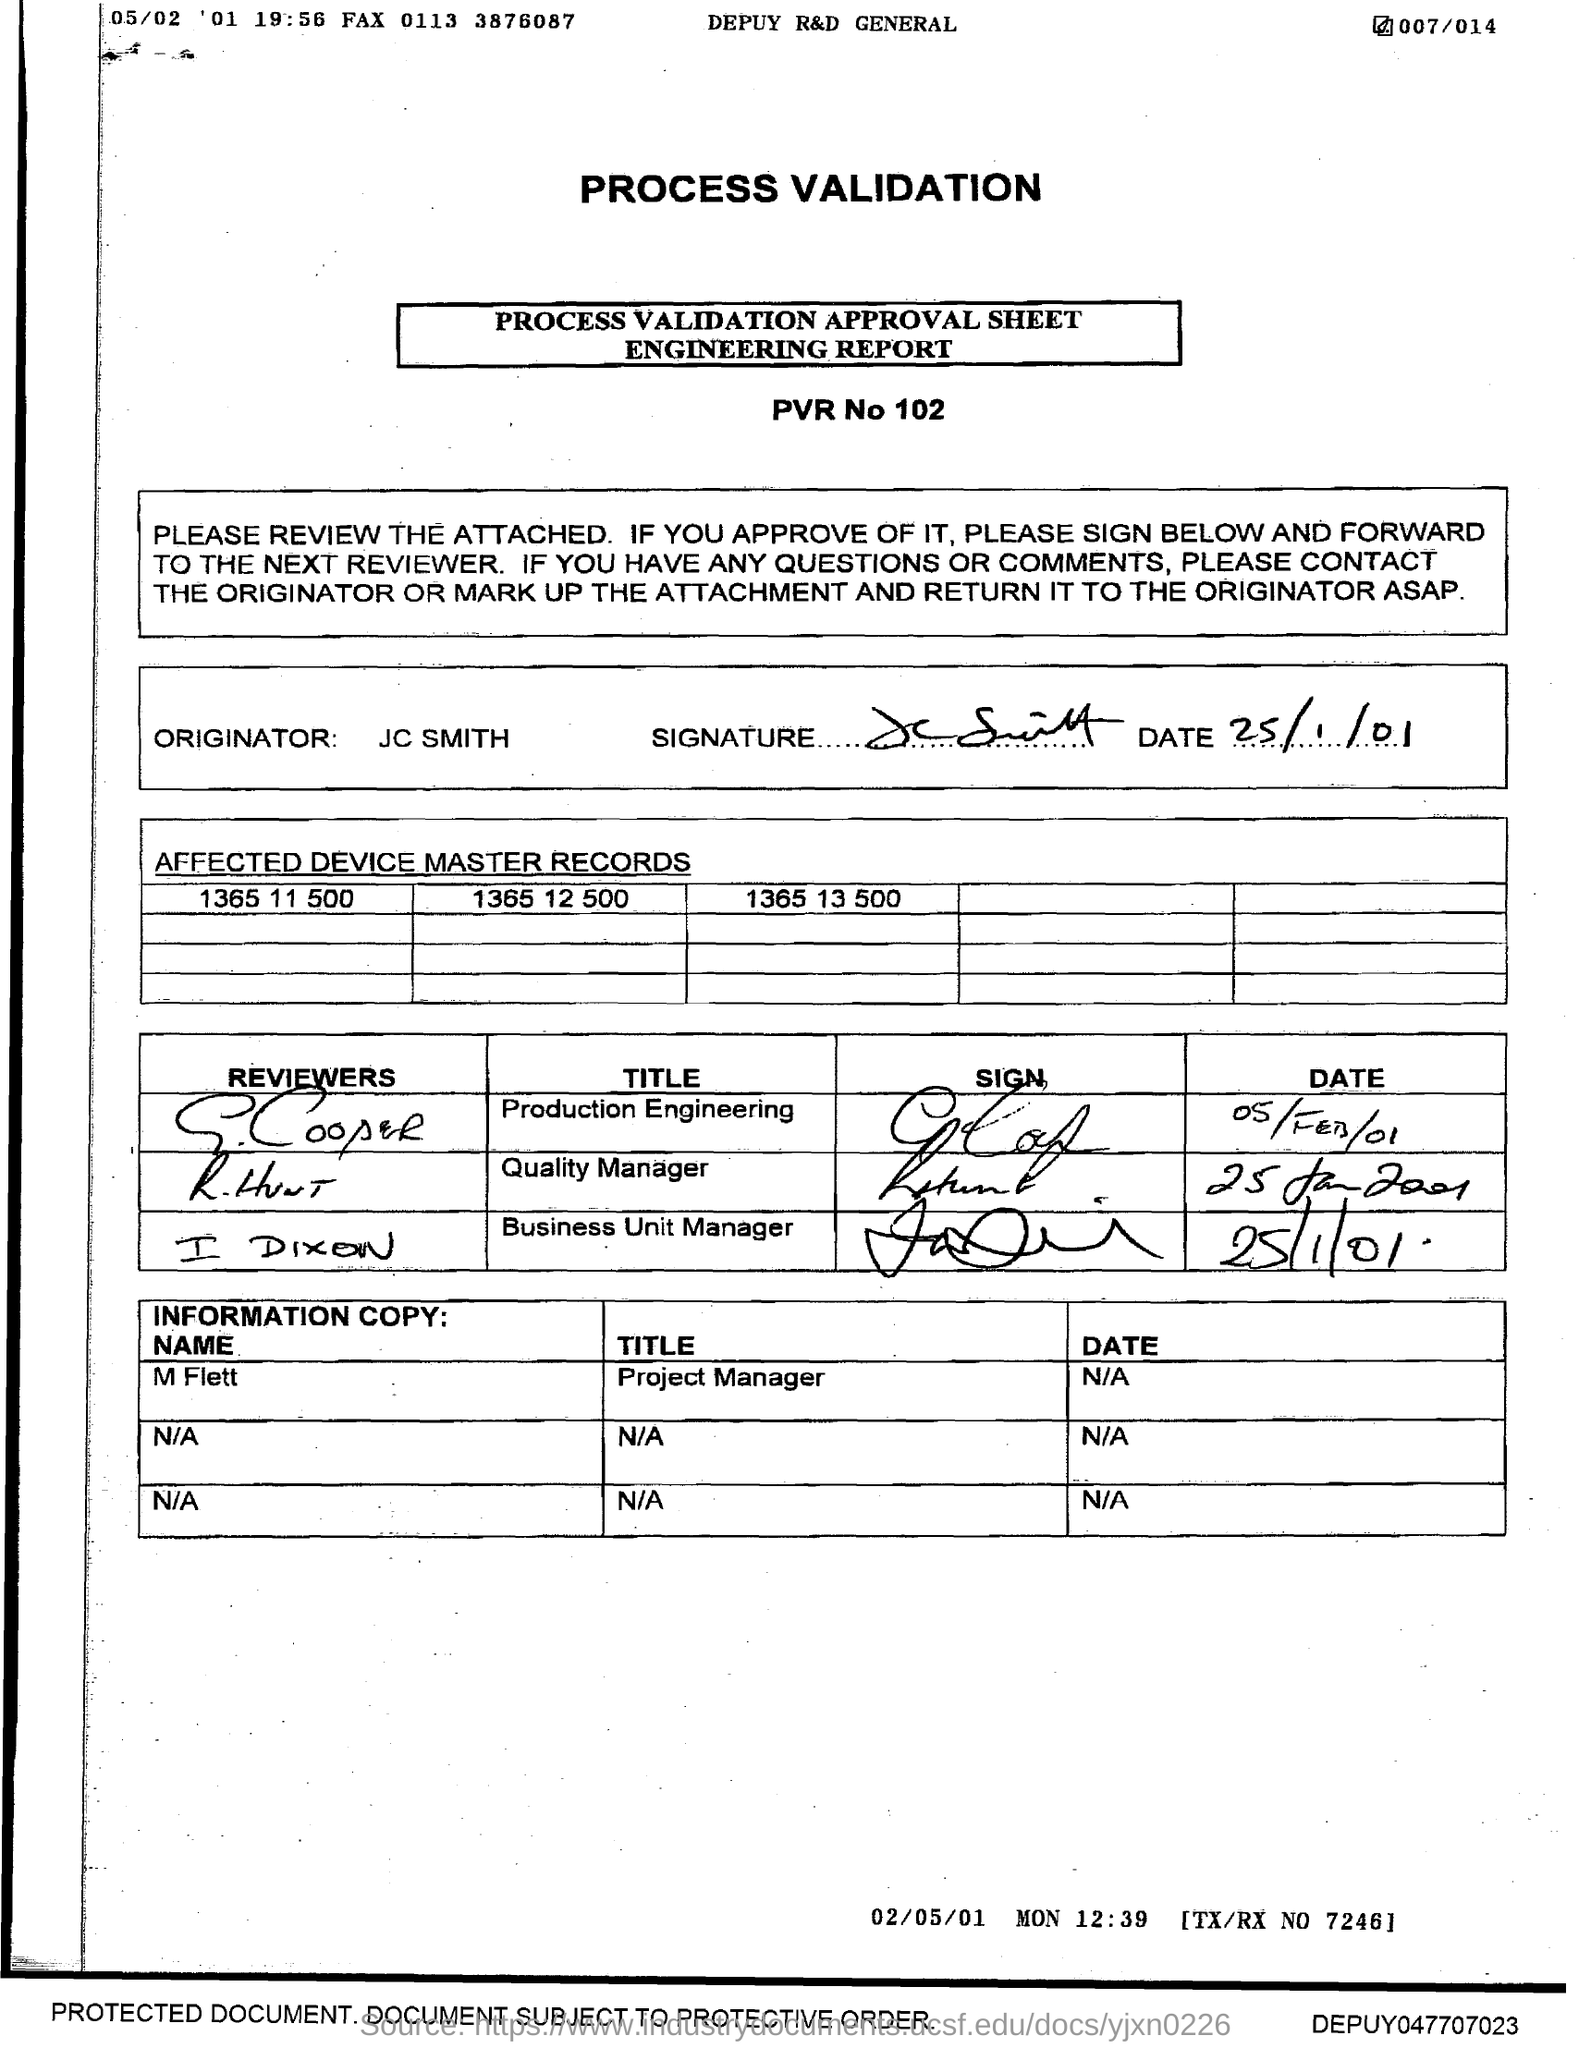What is the PVR no given in the approval sheet?
Provide a short and direct response. 102. Who is the Originator mentioned in the approval sheet?
Keep it short and to the point. JC SMITH. What is the date signed by JC SMITH?
Your response must be concise. 25/1/01. 